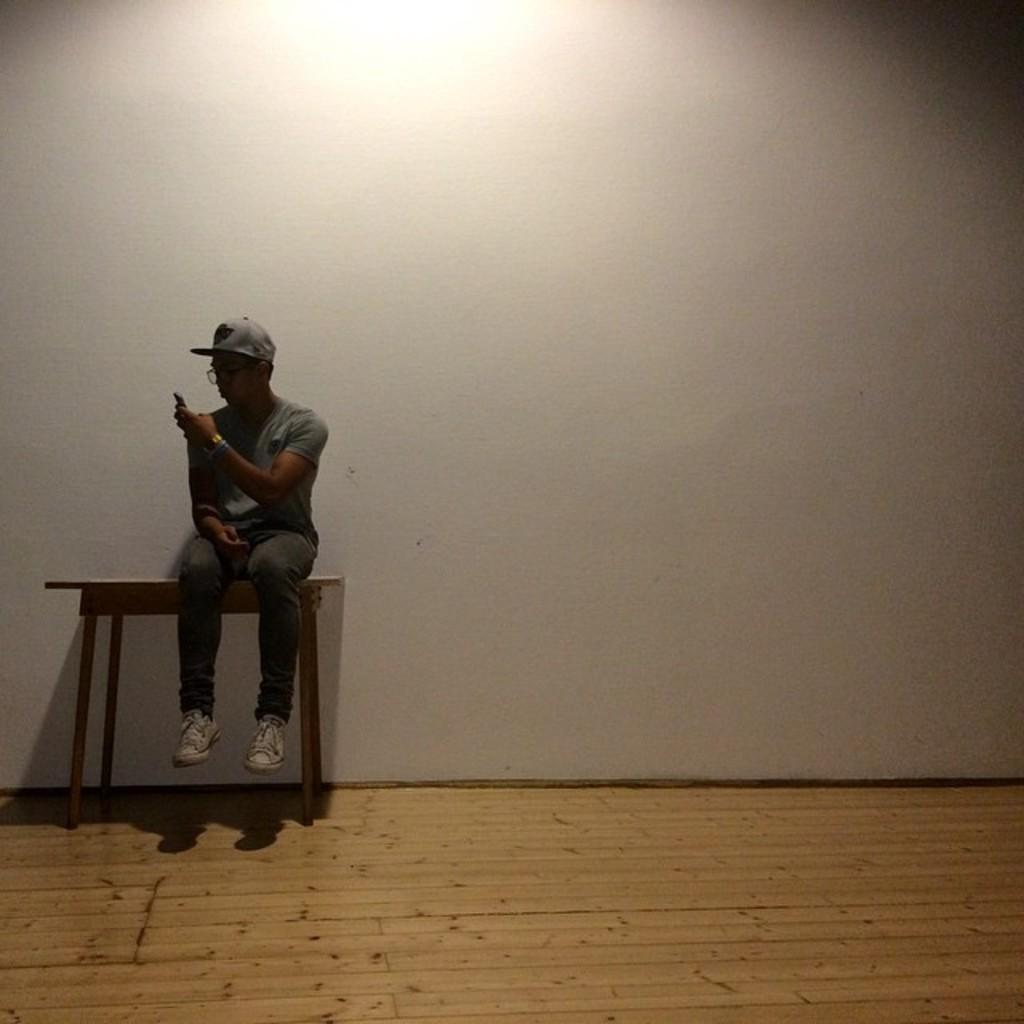What is the person in the image doing? The person is sitting on a table and holding a mobile. What can be seen in the background of the image? There is a light and a white wall in the background of the image. What is the person's tendency to make payments in the image? There is no information about the person's tendency to make payments in the image. 